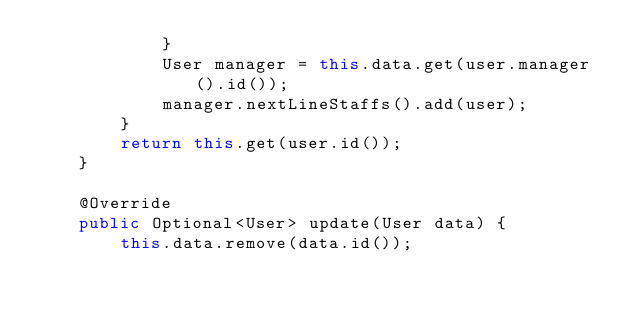Convert code to text. <code><loc_0><loc_0><loc_500><loc_500><_Java_>            }
            User manager = this.data.get(user.manager().id());
            manager.nextLineStaffs().add(user);
        }
        return this.get(user.id());
    }

    @Override
    public Optional<User> update(User data) {
        this.data.remove(data.id());</code> 